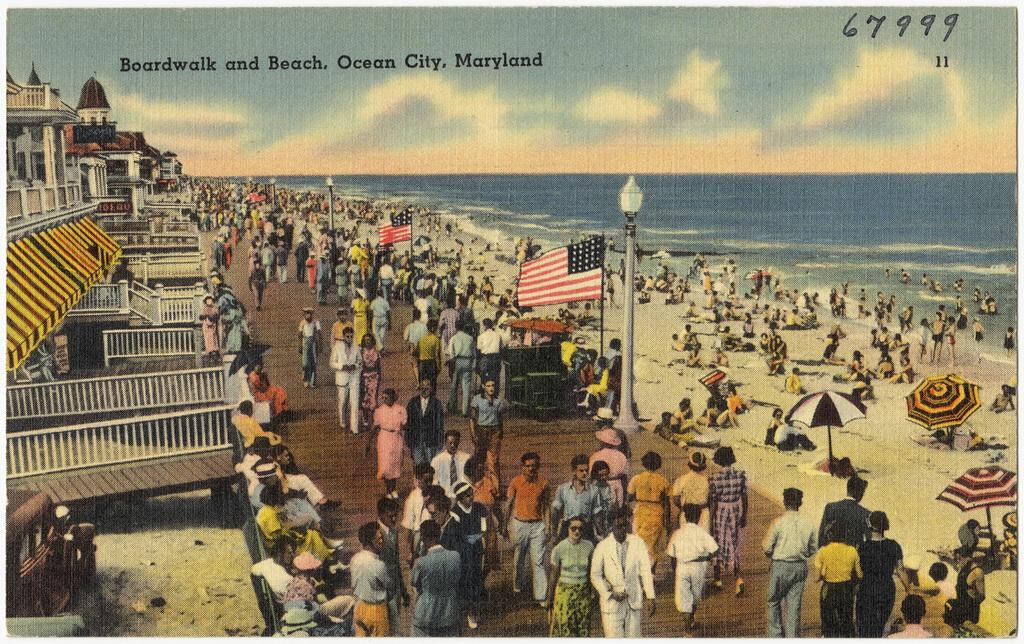<image>
Summarize the visual content of the image. an old postcard with Boardwalk and Beach, Ocean City, Maryland on it. 